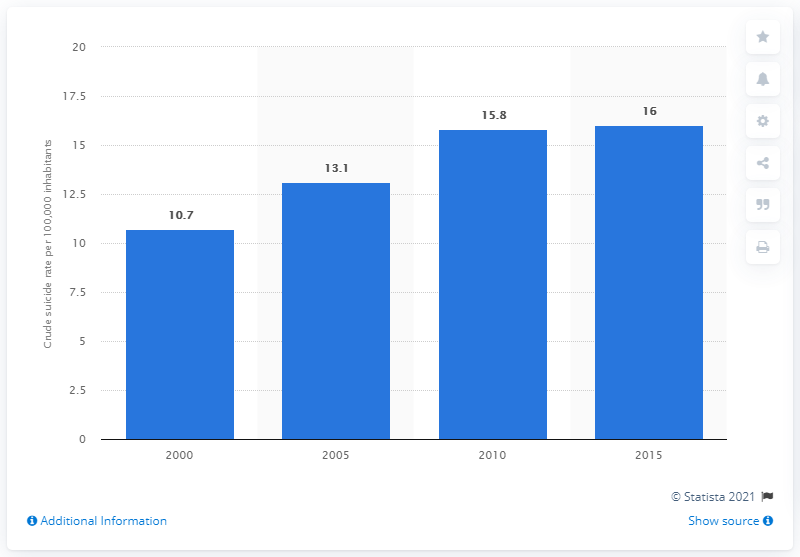Point out several critical features in this image. The sum of all bars is 55.6 and above. In 2010, the value of 15.8 is represented by a blue bar. 